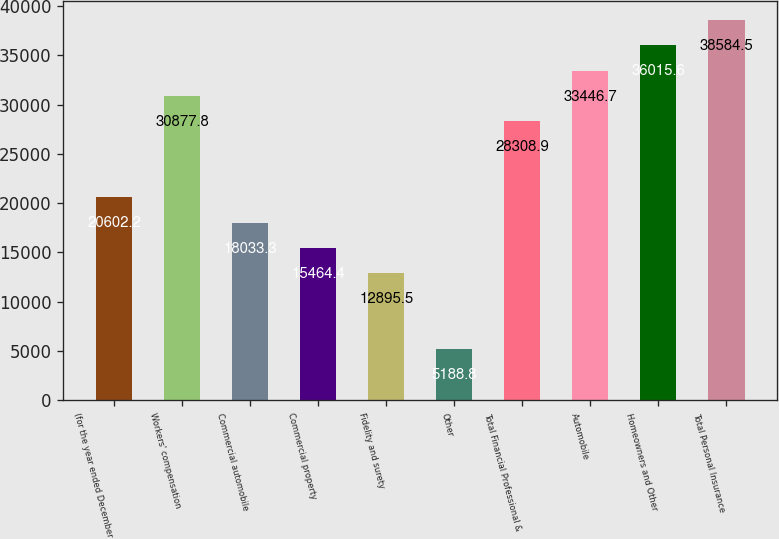<chart> <loc_0><loc_0><loc_500><loc_500><bar_chart><fcel>(for the year ended December<fcel>Workers' compensation<fcel>Commercial automobile<fcel>Commercial property<fcel>Fidelity and surety<fcel>Other<fcel>Total Financial Professional &<fcel>Automobile<fcel>Homeowners and Other<fcel>Total Personal Insurance<nl><fcel>20602.2<fcel>30877.8<fcel>18033.3<fcel>15464.4<fcel>12895.5<fcel>5188.8<fcel>28308.9<fcel>33446.7<fcel>36015.6<fcel>38584.5<nl></chart> 